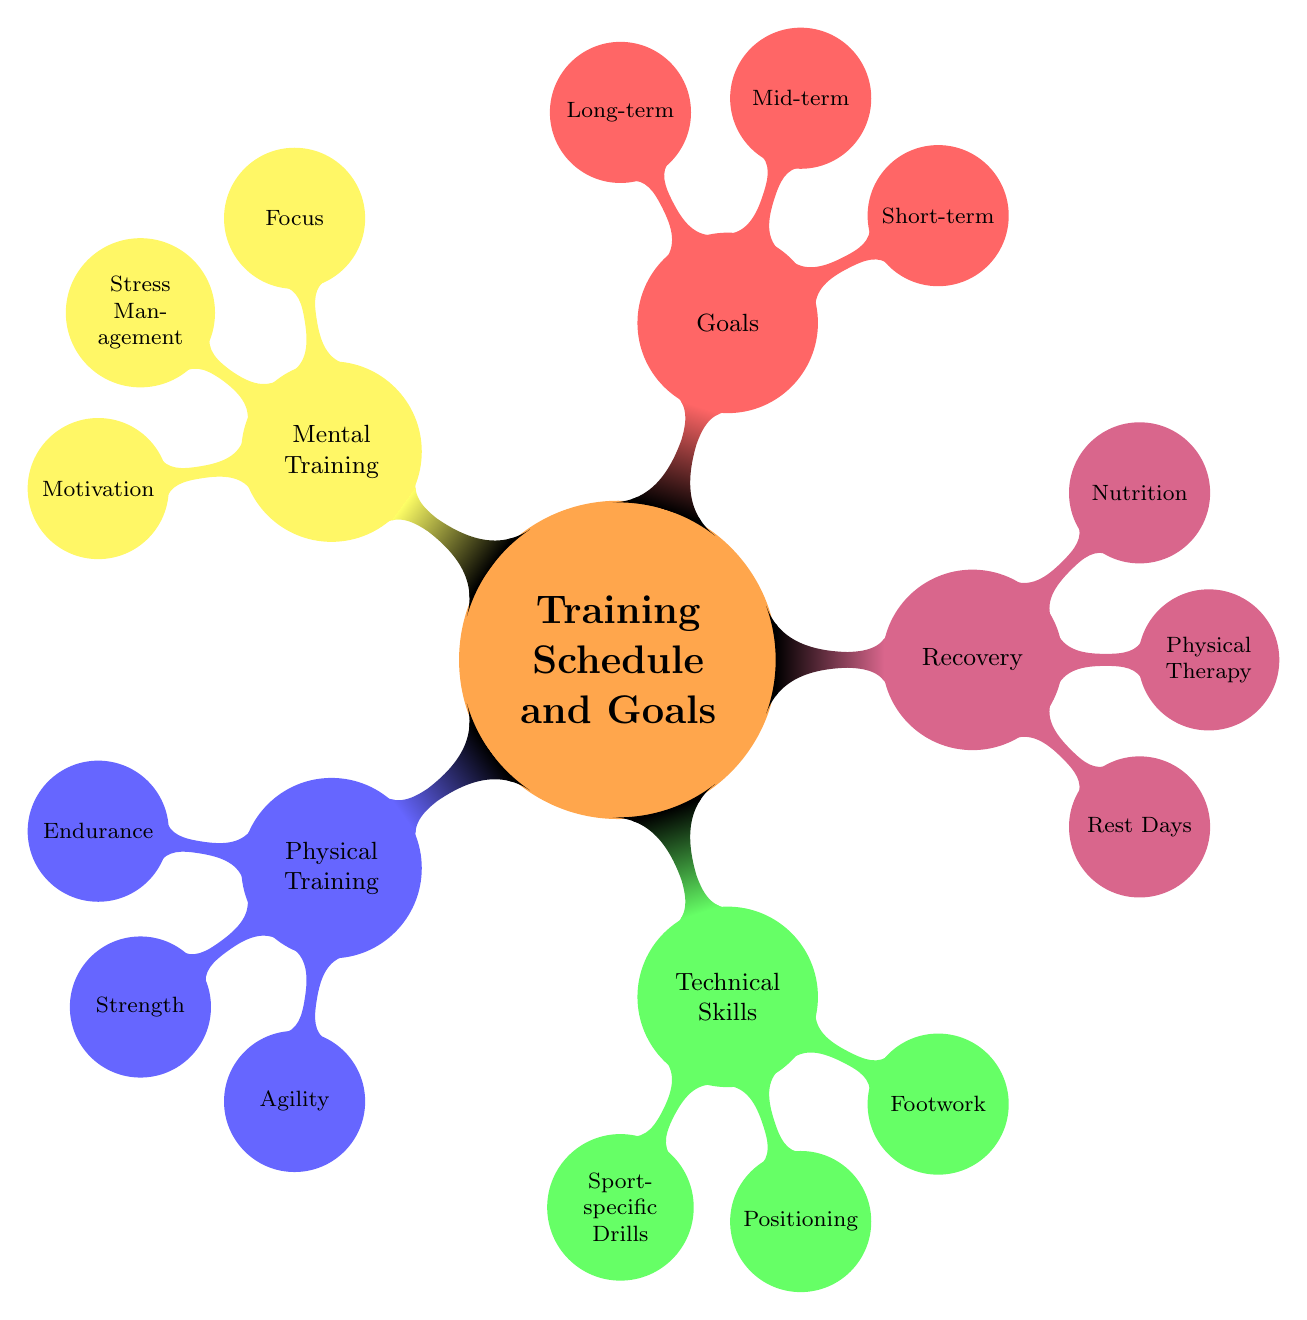What are the main categories in the mind map? The main categories are displayed as the first level of nodes branching from the central theme "Training Schedule and Goals." They include Physical Training, Technical Skills, Recovery, Goals, and Mental Training.
Answer: Physical Training, Technical Skills, Recovery, Goals, Mental Training How many types of recovery methods are listed? The recovery methods are a sub-category under the main category "Recovery." There are three types listed: Rest Days, Physical Therapy, and Nutrition. Counting these reveals there are three types of recovery methods.
Answer: 3 What is one sport-specific drill mentioned? By looking under the "Technical Skills" category, the node for "Sport-specific Drills" has two child nodes. "Dribbling exercises" is one of those mentioned, representing a type of sport-specific drill.
Answer: Dribbling exercises Which category contains agility training? The "Agility" sub-category is a part of the "Physical Training" area. Since "Agility" is directly linked under "Physical Training," this indicates that agility training falls under that category.
Answer: Physical Training What are the long-term goals listed? The long-term goals are represented as child nodes under the "Goals" category. The nodes listed are "Earn MVP award" and "Gain a scholarship." Summarizing these gives the long-term goals outlined in the diagram.
Answer: Earn MVP award, Gain a scholarship What type of exercises are included under stress management? The "Stress Management" node is under the "Mental Training" category. The child nodes listed here are "Breathing exercises" and "Yoga." Identifying these provides the answer to the type of exercises that manage stress.
Answer: Breathing exercises, Yoga How many nodes are there under Technical Skills? The "Technical Skills" category has three child nodes associated with it: "Sport-specific Drills," "Positioning," and "Footwork." Counting these gives the total number of nodes under this category.
Answer: 3 What is a short-term goal mentioned? Short-term goals are the first level of child nodes under the "Goals" category. The list includes "Increase sprint speed by 5%" and "Improve dribbling accuracy." Identifying either of these will answer the question about short-term goals.
Answer: Increase sprint speed by 5% 